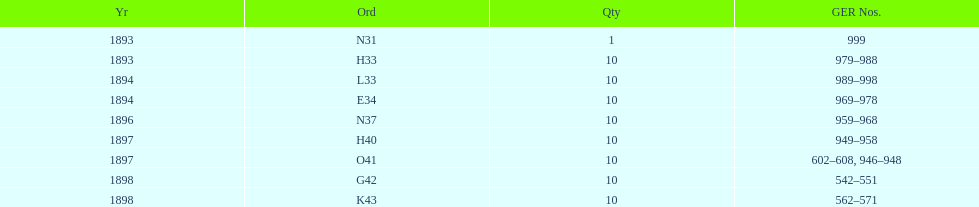Were there more n31 or e34 ordered? E34. 